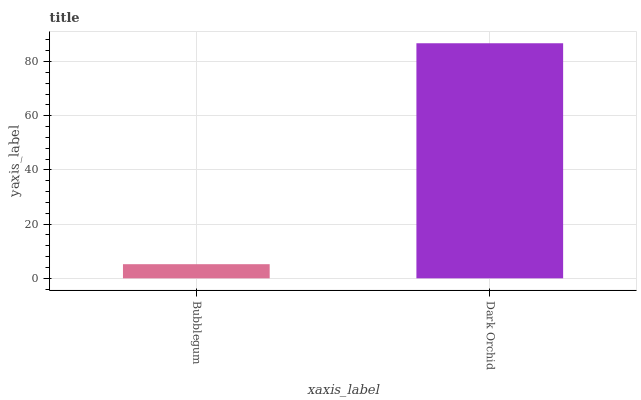Is Bubblegum the minimum?
Answer yes or no. Yes. Is Dark Orchid the maximum?
Answer yes or no. Yes. Is Dark Orchid the minimum?
Answer yes or no. No. Is Dark Orchid greater than Bubblegum?
Answer yes or no. Yes. Is Bubblegum less than Dark Orchid?
Answer yes or no. Yes. Is Bubblegum greater than Dark Orchid?
Answer yes or no. No. Is Dark Orchid less than Bubblegum?
Answer yes or no. No. Is Dark Orchid the high median?
Answer yes or no. Yes. Is Bubblegum the low median?
Answer yes or no. Yes. Is Bubblegum the high median?
Answer yes or no. No. Is Dark Orchid the low median?
Answer yes or no. No. 